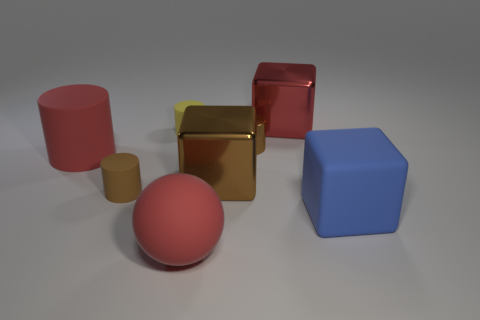There is a small object on the right side of the yellow matte object; is its shape the same as the brown metal thing in front of the red matte cylinder?
Keep it short and to the point. No. What color is the big cube that is behind the red rubber cylinder?
Make the answer very short. Red. Is the number of large red matte things that are in front of the red metal cube less than the number of tiny shiny objects that are right of the brown rubber object?
Offer a very short reply. No. What number of other objects are there of the same material as the yellow thing?
Your response must be concise. 4. Is the material of the small yellow cylinder the same as the blue thing?
Make the answer very short. Yes. What number of other things are the same size as the blue thing?
Your answer should be compact. 4. There is a red matte thing that is left of the red matte object in front of the matte cube; how big is it?
Offer a very short reply. Large. What is the color of the large matte object that is right of the large metal object that is in front of the large red thing behind the tiny shiny cylinder?
Make the answer very short. Blue. How big is the thing that is both behind the brown shiny cylinder and to the left of the big rubber sphere?
Offer a terse response. Small. What number of other objects are there of the same shape as the large red metal object?
Give a very brief answer. 2. 